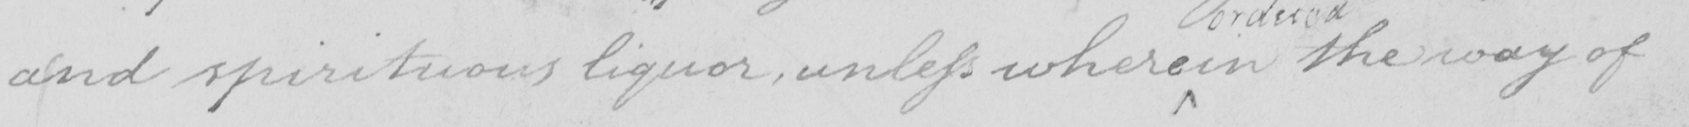What is written in this line of handwriting? and spiritous liquor , unless where in the way of 